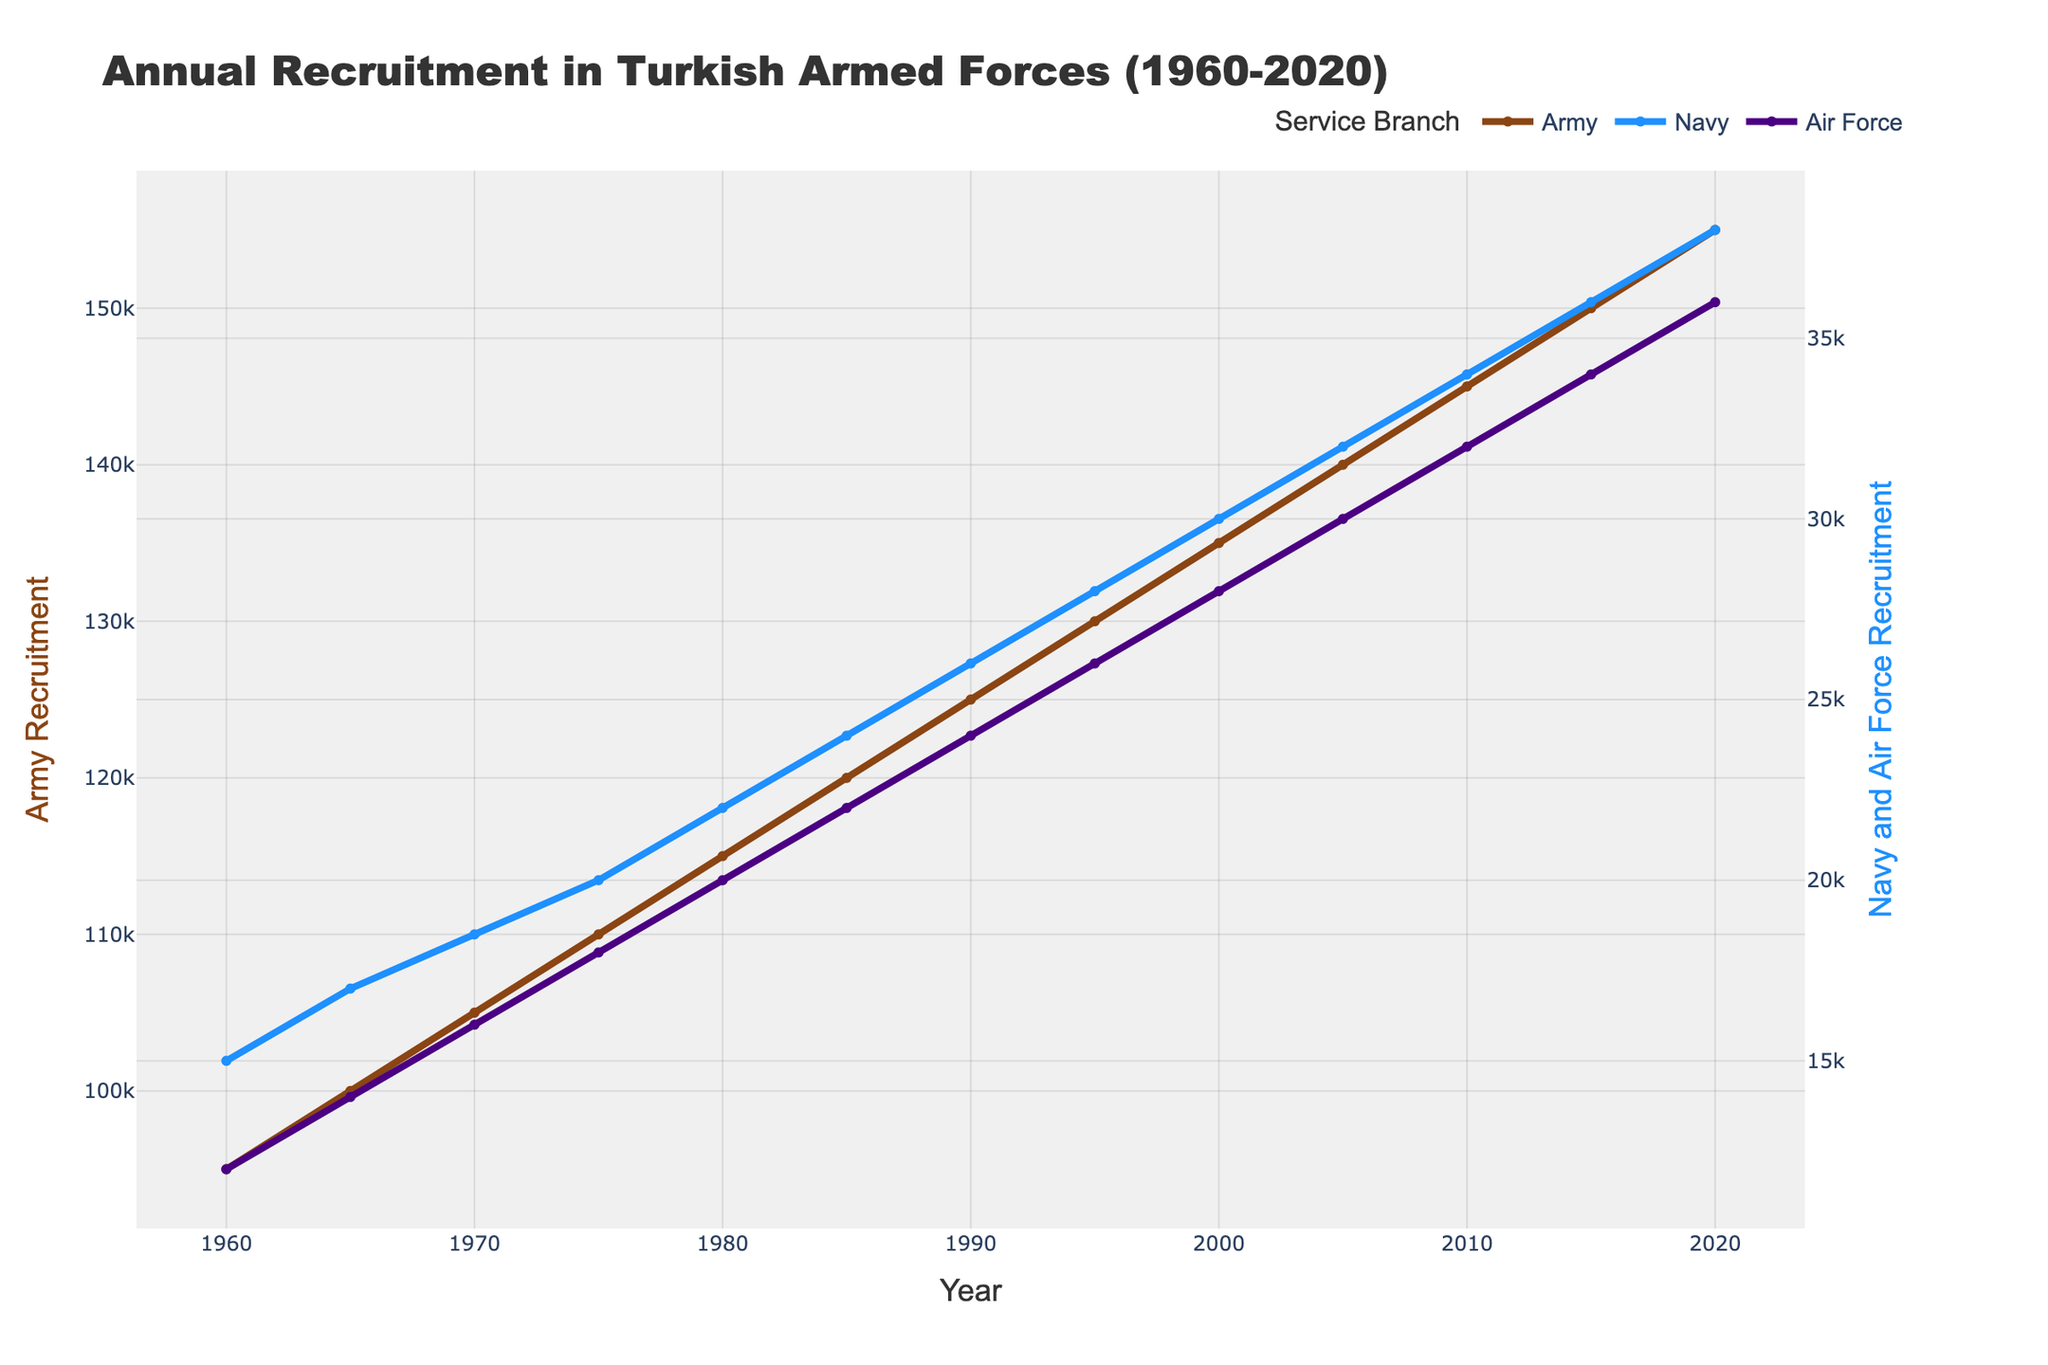What is the total recruitment for the Army in 2000 and 2005? From the figure, locate the values for Army recruitment in the years 2000 and 2005. Add these two values together. For 2000, it's 135,000 and for 2005, it's 140,000. The total is 135,000 + 140,000.
Answer: 275,000 Which branch had the lowest recruitment numbers in 1980? Examine the chart and identify the recruitment numbers for each service branch in 1980. Compare these values: Army (115,000), Navy (22,000), Air Force (20,000). The Air Force had the lowest recruitment in 1980.
Answer: Air Force How did the recruitment for the Navy change from 1960 to 2020? Identify the recruitment numbers for the Navy in 1960 and 2020 on the chart. For 1960, it was 15,000, and for 2020, it was 38,000. Subtract the initial value from the final value: 38,000 - 15,000 = 23,000. The recruitment increased by 23,000.
Answer: Increased by 23,000 Which service branch shows the highest recruitment trend over the years? Observe the slopes of the lines representing each service branch. The steepness of the line for Army recruitment is the greatest, indicating the highest increase.
Answer: Army Is the Air Force recruitment consistently increasing every decade? Check the data points for Air Force recruitment every 10 years (1960, 1970, 1980, 1990, 2000, 2010, 2020). The values are 12,000 (1960), 16,000 (1970), 20,000 (1980), 24,000 (1990), 28,000 (2000), 32,000 (2010), 36,000 (2020). Each decade shows an increase from the previous one.
Answer: Yes By how much did Army recruitment increase from 1960 to 1975? Look at the values for Army recruitment in 1960 and 1975 from the figure. For 1960, it’s 95,000, and for 1975, it’s 110,000. Calculate the difference: 110,000 - 95,000 = 15,000.
Answer: 15,000 Compare the total recruitment for all branches in 1965 and 2015. Sum the recruitment numbers for Army, Navy, and Air Force in 1965 and 2015. For 1965: 100,000 (Army) + 17,000 (Navy) + 14,000 (Air Force) = 131,000. For 2015: 150,000 (Army) + 36,000 (Navy) + 34,000 (Air Force) = 220,000. Now compare the totals.
Answer: 89,000 more in 2015 What is the average recruitment for the Navy between 1970 and 2000? Extract the recruitment numbers for the Navy in the years 1970, 1975, 1980, 1985, 1990, 1995, and 2000 from the figure. The values are 18,500, 20,000, 22,000, 24,000, 26,000, 28,000, and 30,000. Calculate the average: (18,500 + 20,000 + 22,000 + 24,000 + 26,000 + 28,000 + 30,000) / 7.
Answer: 24,214 